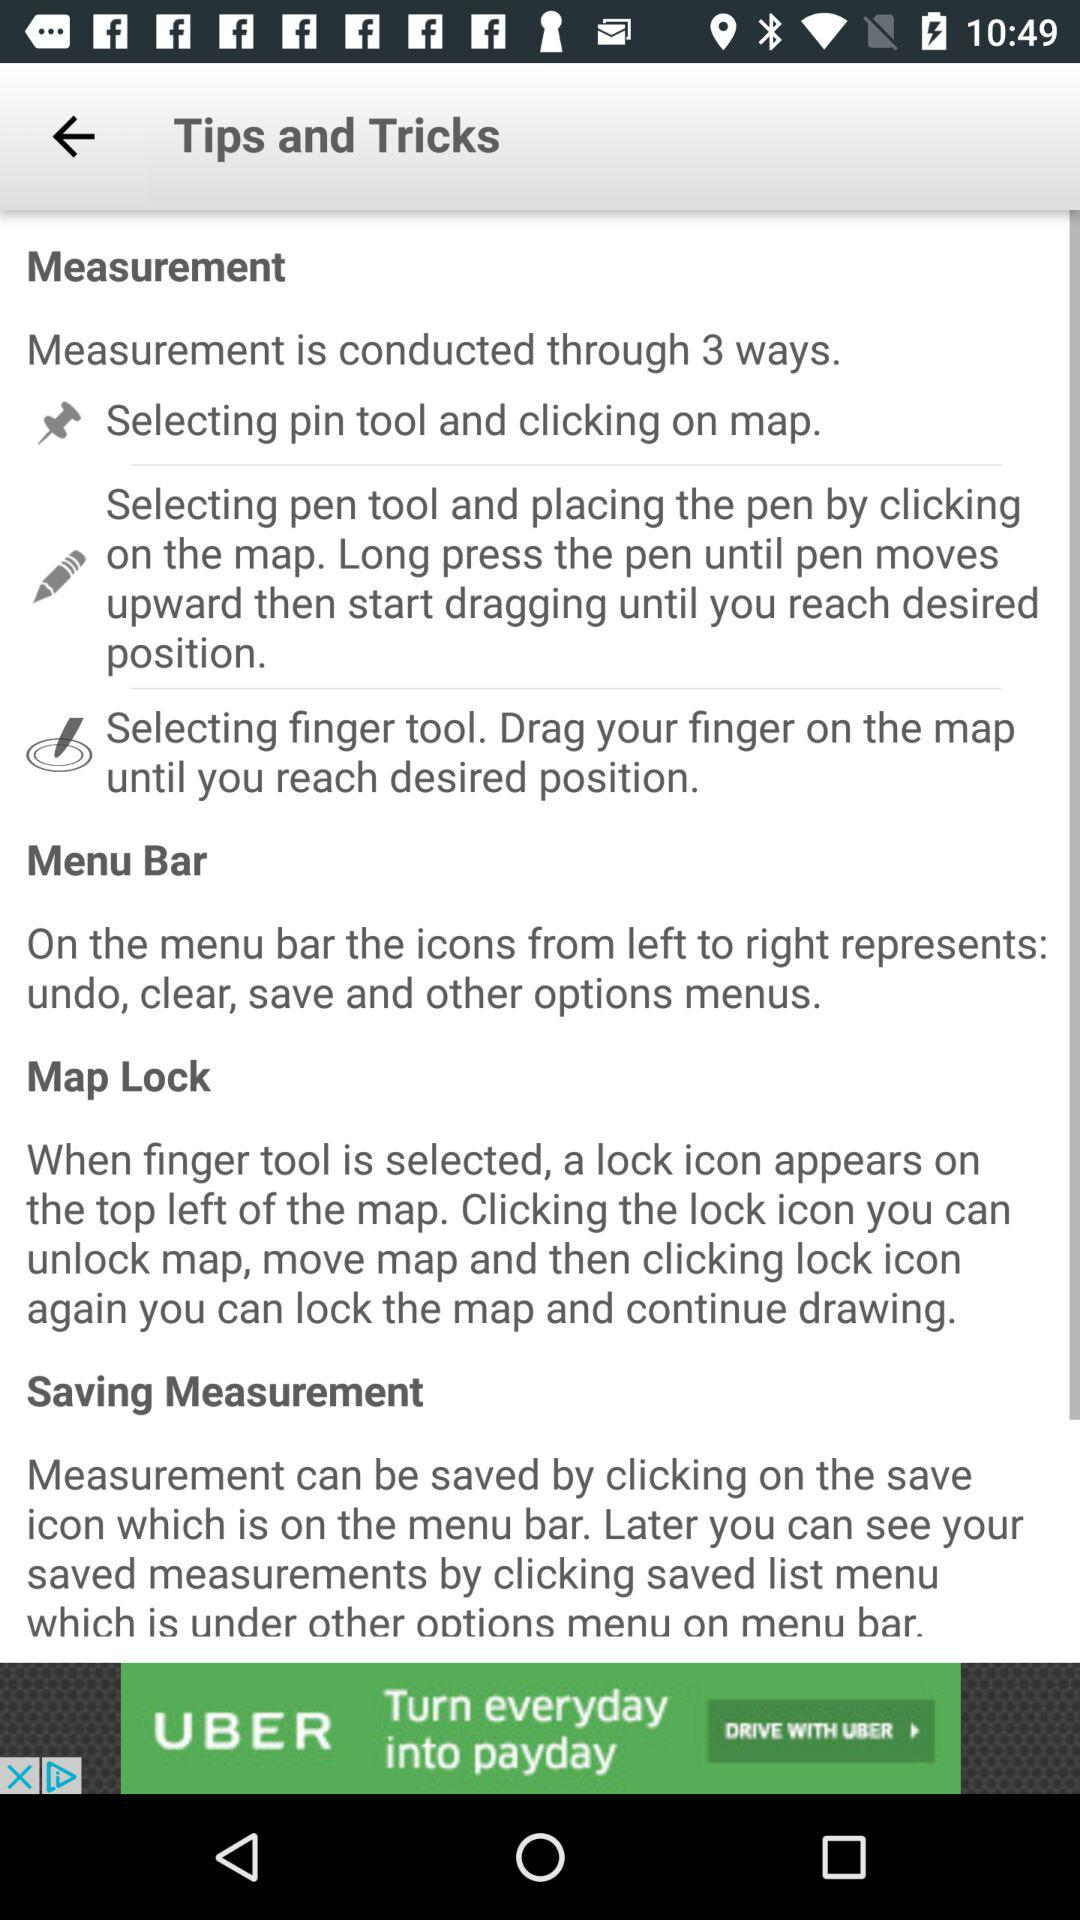How many types of measurements are there?
Answer the question using a single word or phrase. 3 